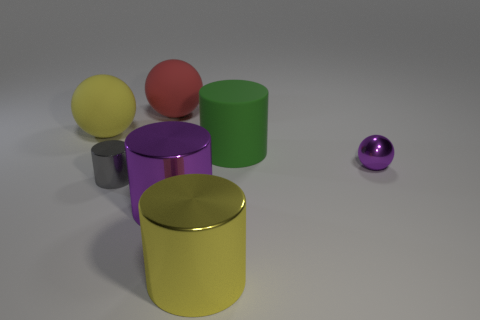Is the number of green cylinders to the right of the purple metallic ball less than the number of large matte balls that are behind the yellow rubber thing? Yes, the number of green cylinders to the right of the purple metallic ball, which is one, is indeed less than the number of large matte balls behind the yellow rubber object, as there are two large matte balls visible behind the yellow cylinder. 